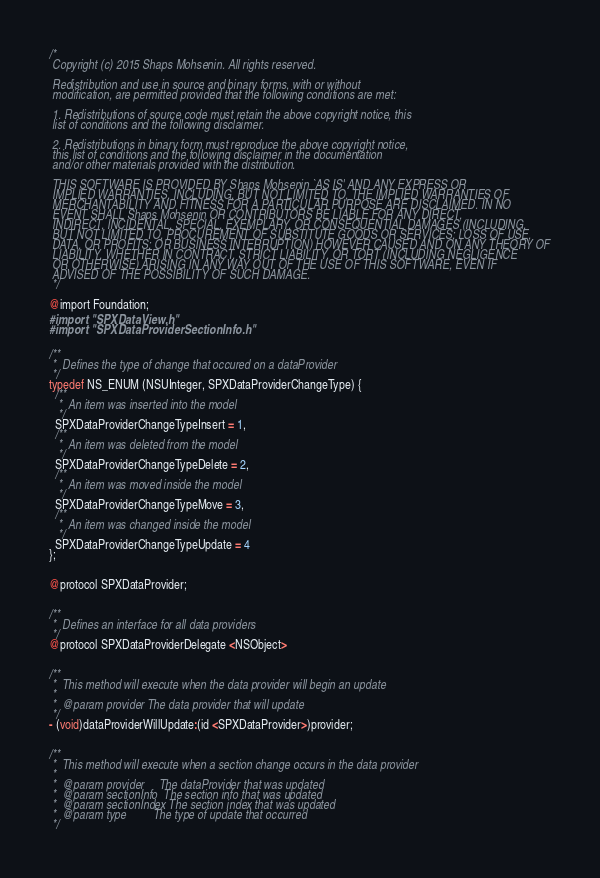Convert code to text. <code><loc_0><loc_0><loc_500><loc_500><_C_>/*
 Copyright (c) 2015 Shaps Mohsenin. All rights reserved.
 
 Redistribution and use in source and binary forms, with or without
 modification, are permitted provided that the following conditions are met:
 
 1. Redistributions of source code must retain the above copyright notice, this
 list of conditions and the following disclaimer.
 
 2. Redistributions in binary form must reproduce the above copyright notice,
 this list of conditions and the following disclaimer in the documentation
 and/or other materials provided with the distribution.
 
 THIS SOFTWARE IS PROVIDED BY Shaps Mohsenin `AS IS' AND ANY EXPRESS OR
 IMPLIED WARRANTIES, INCLUDING, BUT NOT LIMITED TO, THE IMPLIED WARRANTIES OF
 MERCHANTABILITY AND FITNESS FOR A PARTICULAR PURPOSE ARE DISCLAIMED. IN NO
 EVENT SHALL Shaps Mohsenin OR CONTRIBUTORS BE LIABLE FOR ANY DIRECT,
 INDIRECT, INCIDENTAL, SPECIAL, EXEMPLARY, OR CONSEQUENTIAL DAMAGES (INCLUDING,
 BUT NOT LIMITED TO, PROCUREMENT OF SUBSTITUTE GOODS OR SERVICES; LOSS OF USE,
 DATA, OR PROFITS; OR BUSINESS INTERRUPTION) HOWEVER CAUSED AND ON ANY THEORY OF
 LIABILITY, WHETHER IN CONTRACT, STRICT LIABILITY, OR TORT (INCLUDING NEGLIGENCE
 OR OTHERWISE) ARISING IN ANY WAY OUT OF THE USE OF THIS SOFTWARE, EVEN IF
 ADVISED OF THE POSSIBILITY OF SUCH DAMAGE.
 */

@import Foundation;
#import "SPXDataView.h"
#import "SPXDataProviderSectionInfo.h"


/**
 *  Defines the type of change that occured on a dataProvider
 */
typedef NS_ENUM (NSUInteger, SPXDataProviderChangeType) {
  /**
   *  An item was inserted into the model
   */
  SPXDataProviderChangeTypeInsert = 1,
  /**
   *  An item was deleted from the model
   */
  SPXDataProviderChangeTypeDelete = 2,
  /**
   *  An item was moved inside the model
   */
  SPXDataProviderChangeTypeMove = 3,
  /**
   *  An item was changed inside the model
   */
  SPXDataProviderChangeTypeUpdate = 4
};


@protocol SPXDataProvider;


/**
 *  Defines an interface for all data providers
 */
@protocol SPXDataProviderDelegate <NSObject>


/**
 *  This method will execute when the data provider will begin an update
 *
 *  @param provider The data provider that will update
 */
- (void)dataProviderWillUpdate:(id <SPXDataProvider>)provider;


/**
 *  This method will execute when a section change occurs in the data provider
 *
 *  @param provider     The dataProvider that was updated
 *  @param sectionInfo  The section info that was updated
 *  @param sectionIndex The section index that was updated
 *  @param type         The type of update that occurred
 */</code> 